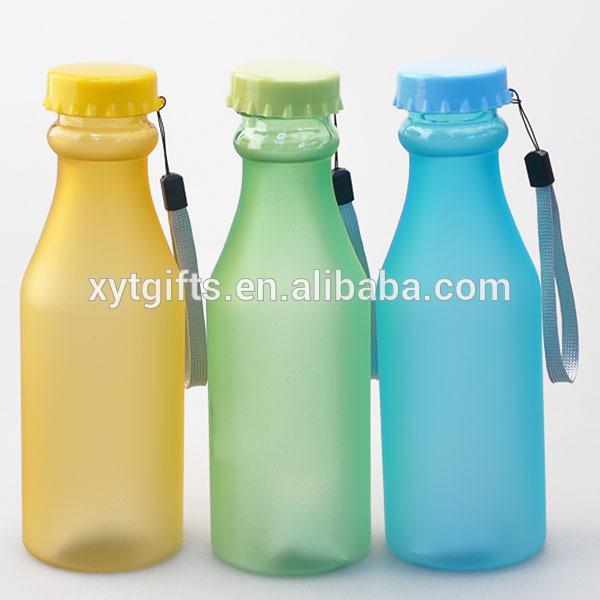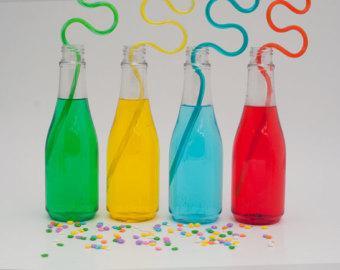The first image is the image on the left, the second image is the image on the right. For the images displayed, is the sentence "There are no more than 3 bottles in the image on the left." factually correct? Answer yes or no. Yes. The first image is the image on the left, the second image is the image on the right. Considering the images on both sides, is "All bottles contain colored liquids and have labels and caps on." valid? Answer yes or no. No. 